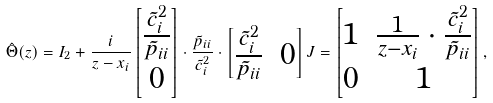<formula> <loc_0><loc_0><loc_500><loc_500>\hat { \Theta } ( z ) = I _ { 2 } + \frac { i } { z - x _ { i } } \begin{bmatrix} \frac { \tilde { c } _ { i } ^ { 2 } } { \tilde { p } _ { i i } } \\ 0 \end{bmatrix} \cdot \frac { \tilde { p } _ { i i } } { \tilde { c } _ { i } ^ { 2 } } \cdot \begin{bmatrix} \frac { \tilde { c } _ { i } ^ { 2 } } { \tilde { p } _ { i i } } & 0 \end{bmatrix} J = \begin{bmatrix} 1 & \frac { 1 } { z - x _ { i } } \cdot \frac { \tilde { c } _ { i } ^ { 2 } } { \tilde { p } _ { i i } } \\ 0 & 1 \end{bmatrix} ,</formula> 